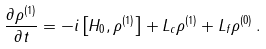<formula> <loc_0><loc_0><loc_500><loc_500>\frac { \partial \rho ^ { ( 1 ) } } { \partial t } = - i \left [ H _ { 0 } , \rho ^ { ( 1 ) } \right ] + L _ { c } \rho ^ { ( 1 ) } + L _ { f } \rho ^ { ( 0 ) } \, .</formula> 